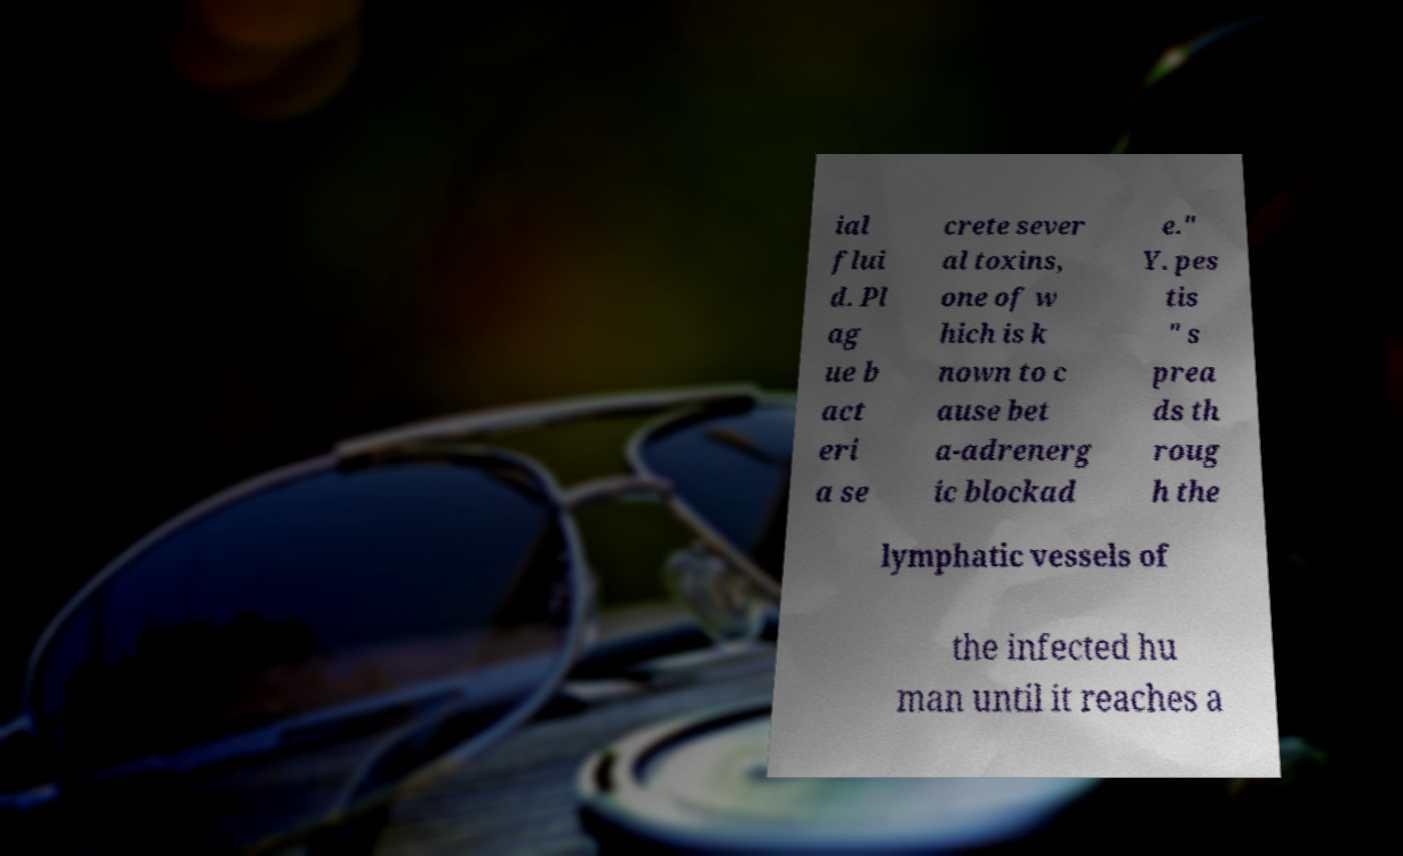Could you assist in decoding the text presented in this image and type it out clearly? ial flui d. Pl ag ue b act eri a se crete sever al toxins, one of w hich is k nown to c ause bet a-adrenerg ic blockad e." Y. pes tis " s prea ds th roug h the lymphatic vessels of the infected hu man until it reaches a 